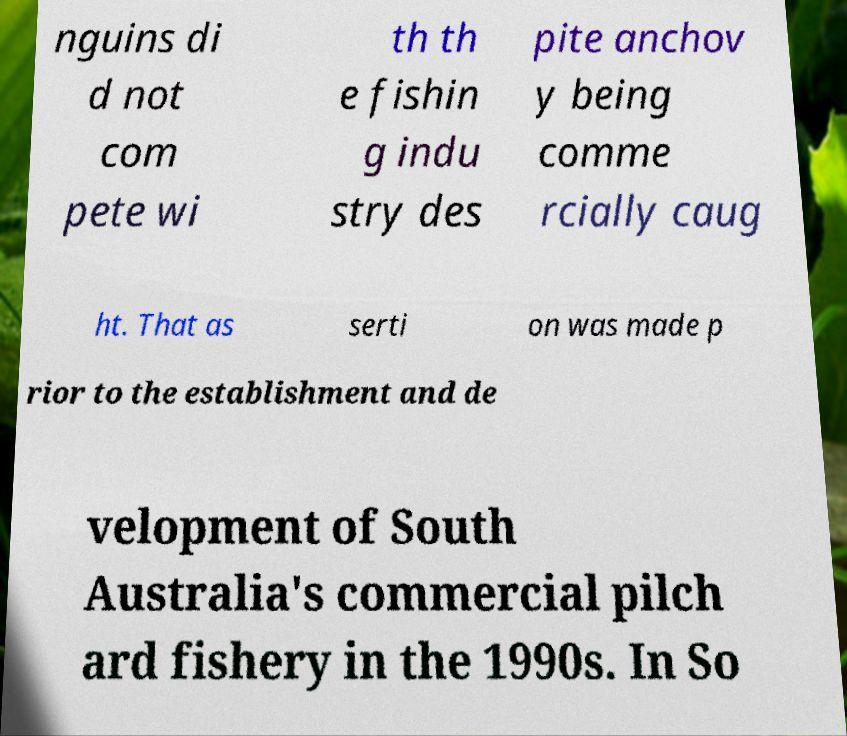Could you extract and type out the text from this image? nguins di d not com pete wi th th e fishin g indu stry des pite anchov y being comme rcially caug ht. That as serti on was made p rior to the establishment and de velopment of South Australia's commercial pilch ard fishery in the 1990s. In So 